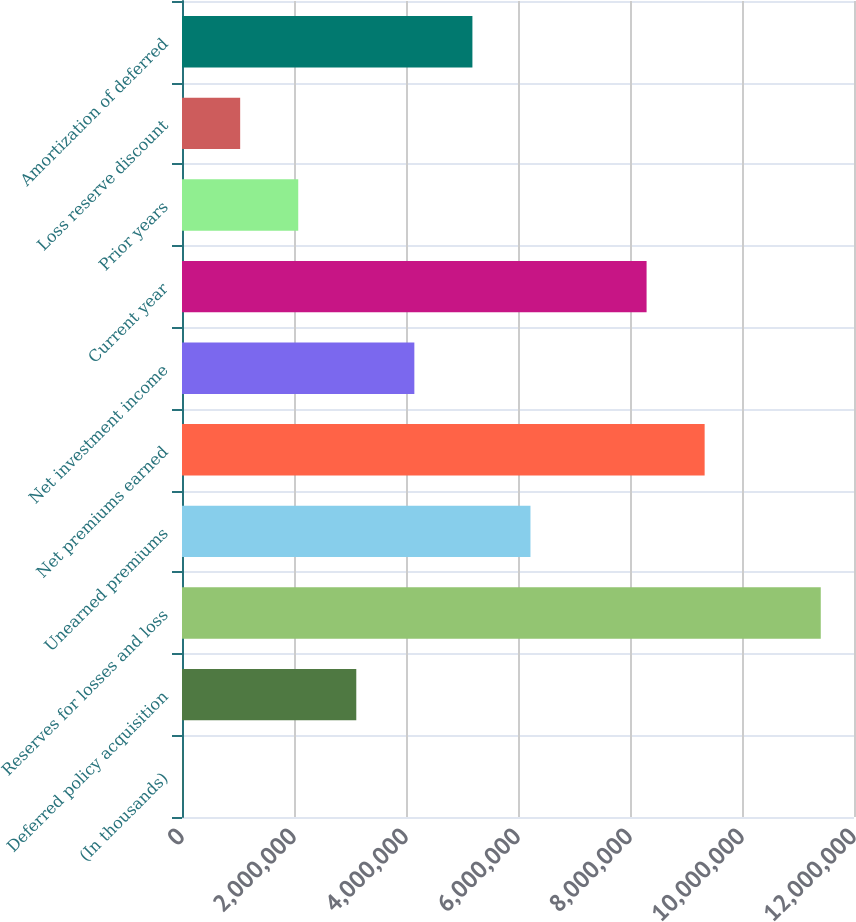<chart> <loc_0><loc_0><loc_500><loc_500><bar_chart><fcel>(In thousands)<fcel>Deferred policy acquisition<fcel>Reserves for losses and loss<fcel>Unearned premiums<fcel>Net premiums earned<fcel>Net investment income<fcel>Current year<fcel>Prior years<fcel>Loss reserve discount<fcel>Amortization of deferred<nl><fcel>2014<fcel>3.11232e+06<fcel>1.14065e+07<fcel>6.22263e+06<fcel>9.33293e+06<fcel>4.14909e+06<fcel>8.29616e+06<fcel>2.07555e+06<fcel>1.03878e+06<fcel>5.18586e+06<nl></chart> 